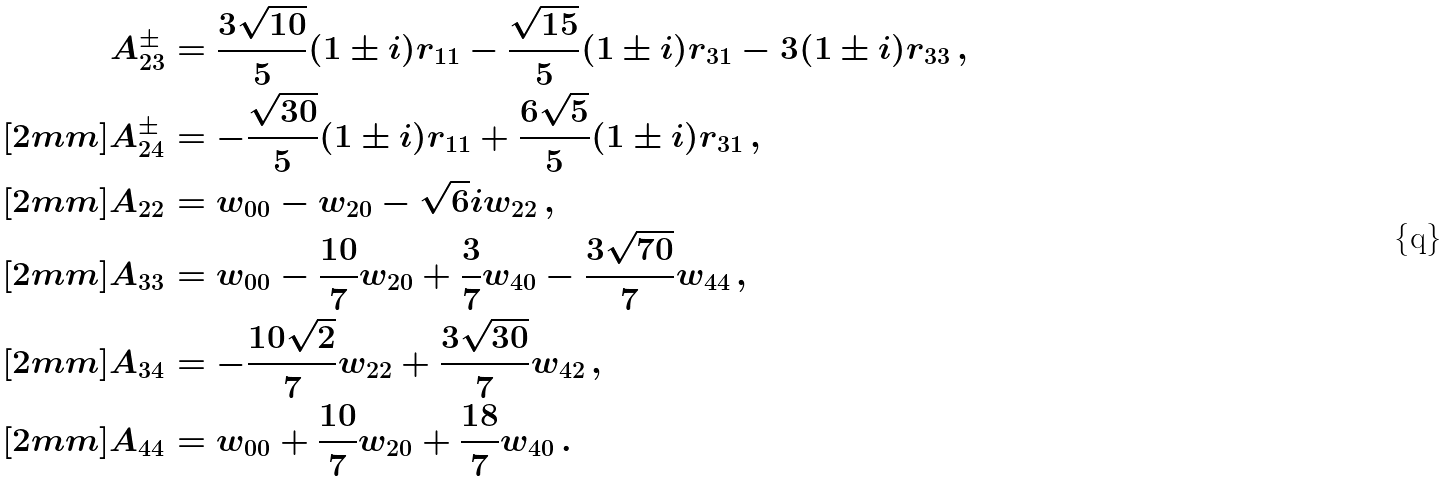Convert formula to latex. <formula><loc_0><loc_0><loc_500><loc_500>A _ { 2 3 } ^ { \pm } & = \frac { 3 \sqrt { 1 0 } } { 5 } ( 1 \pm i ) r _ { 1 1 } - \frac { \sqrt { 1 5 } } { 5 } ( 1 \pm i ) r _ { 3 1 } - 3 ( 1 \pm i ) r _ { 3 3 } \, , \\ [ 2 m m ] A _ { 2 4 } ^ { \pm } & = - \frac { \sqrt { 3 0 } } { 5 } ( 1 \pm i ) r _ { 1 1 } + \frac { 6 \sqrt { 5 } } { 5 } ( 1 \pm i ) r _ { 3 1 } \, , \\ [ 2 m m ] A _ { 2 2 } & = w _ { 0 0 } - w _ { 2 0 } - \sqrt { 6 } i w _ { 2 2 } \, , \\ [ 2 m m ] A _ { 3 3 } & = w _ { 0 0 } - \frac { 1 0 } { 7 } w _ { 2 0 } + \frac { 3 } { 7 } w _ { 4 0 } - \frac { 3 \sqrt { 7 0 } } { 7 } w _ { 4 4 } \, , \\ [ 2 m m ] A _ { 3 4 } & = - \frac { 1 0 \sqrt { 2 } } { 7 } w _ { 2 2 } + \frac { 3 \sqrt { 3 0 } } { 7 } w _ { 4 2 } \, , \\ [ 2 m m ] A _ { 4 4 } & = w _ { 0 0 } + \frac { 1 0 } { 7 } w _ { 2 0 } + \frac { 1 8 } { 7 } w _ { 4 0 } \, .</formula> 